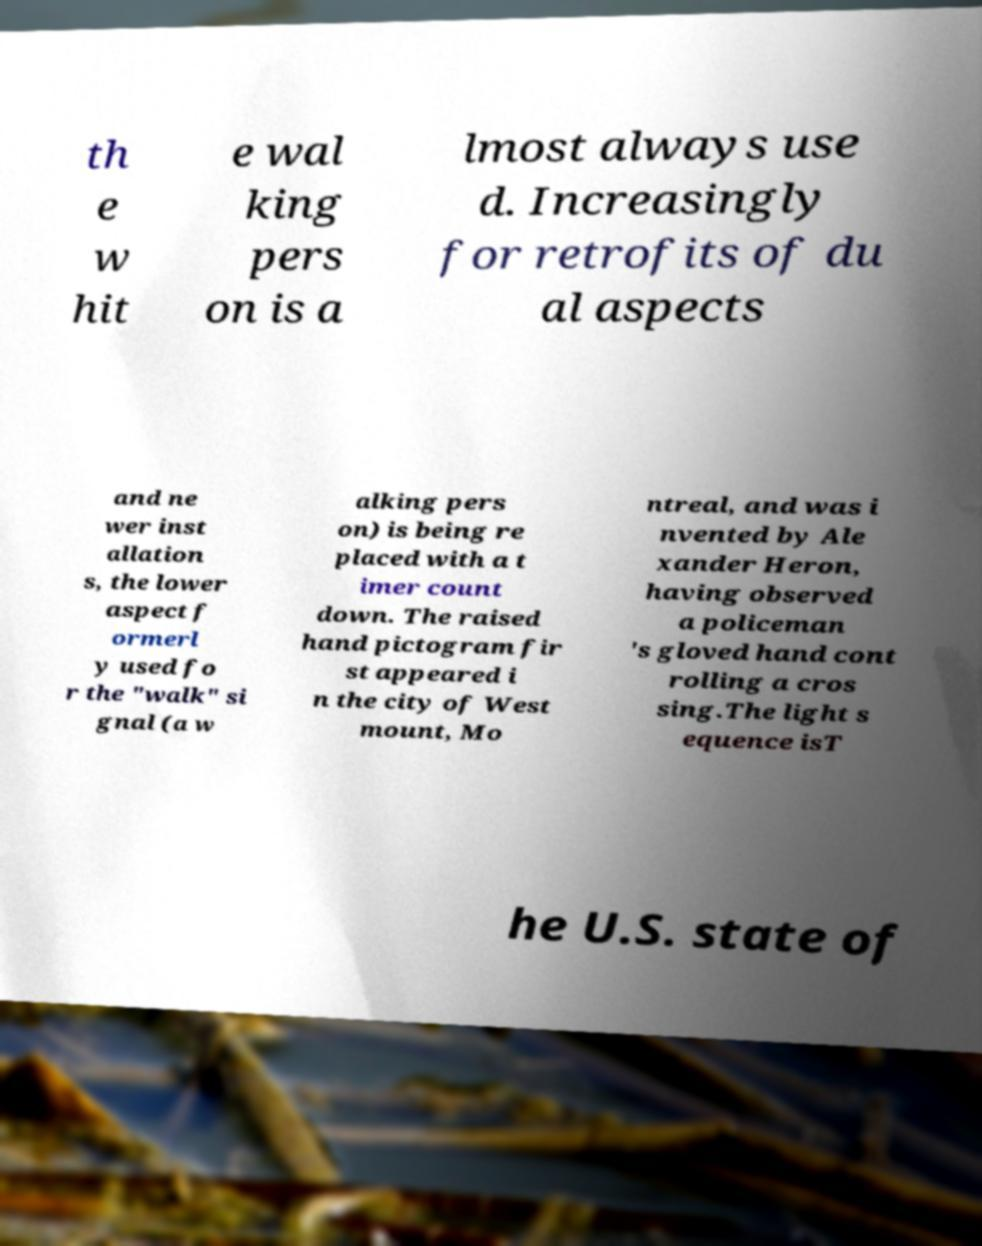Please identify and transcribe the text found in this image. th e w hit e wal king pers on is a lmost always use d. Increasingly for retrofits of du al aspects and ne wer inst allation s, the lower aspect f ormerl y used fo r the "walk" si gnal (a w alking pers on) is being re placed with a t imer count down. The raised hand pictogram fir st appeared i n the city of West mount, Mo ntreal, and was i nvented by Ale xander Heron, having observed a policeman 's gloved hand cont rolling a cros sing.The light s equence isT he U.S. state of 